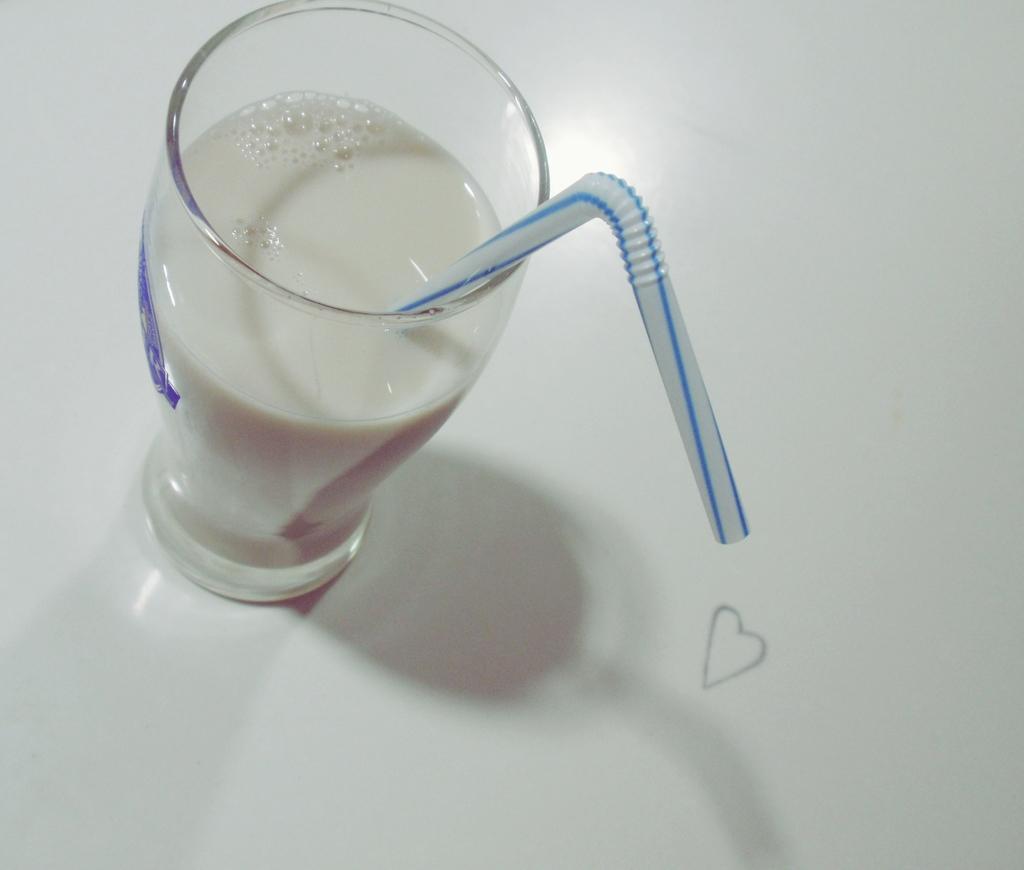Could you give a brief overview of what you see in this image? In this image I can see the glass. In the glass I can see the liquid in white color and I can also a white color straw and the glass is on the white color surface. 